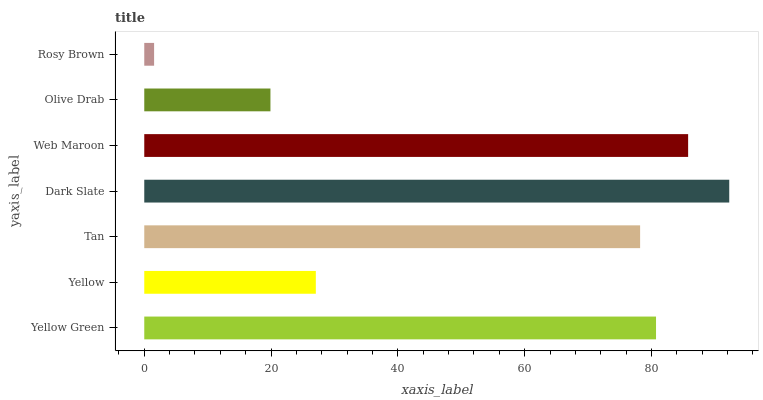Is Rosy Brown the minimum?
Answer yes or no. Yes. Is Dark Slate the maximum?
Answer yes or no. Yes. Is Yellow the minimum?
Answer yes or no. No. Is Yellow the maximum?
Answer yes or no. No. Is Yellow Green greater than Yellow?
Answer yes or no. Yes. Is Yellow less than Yellow Green?
Answer yes or no. Yes. Is Yellow greater than Yellow Green?
Answer yes or no. No. Is Yellow Green less than Yellow?
Answer yes or no. No. Is Tan the high median?
Answer yes or no. Yes. Is Tan the low median?
Answer yes or no. Yes. Is Web Maroon the high median?
Answer yes or no. No. Is Web Maroon the low median?
Answer yes or no. No. 